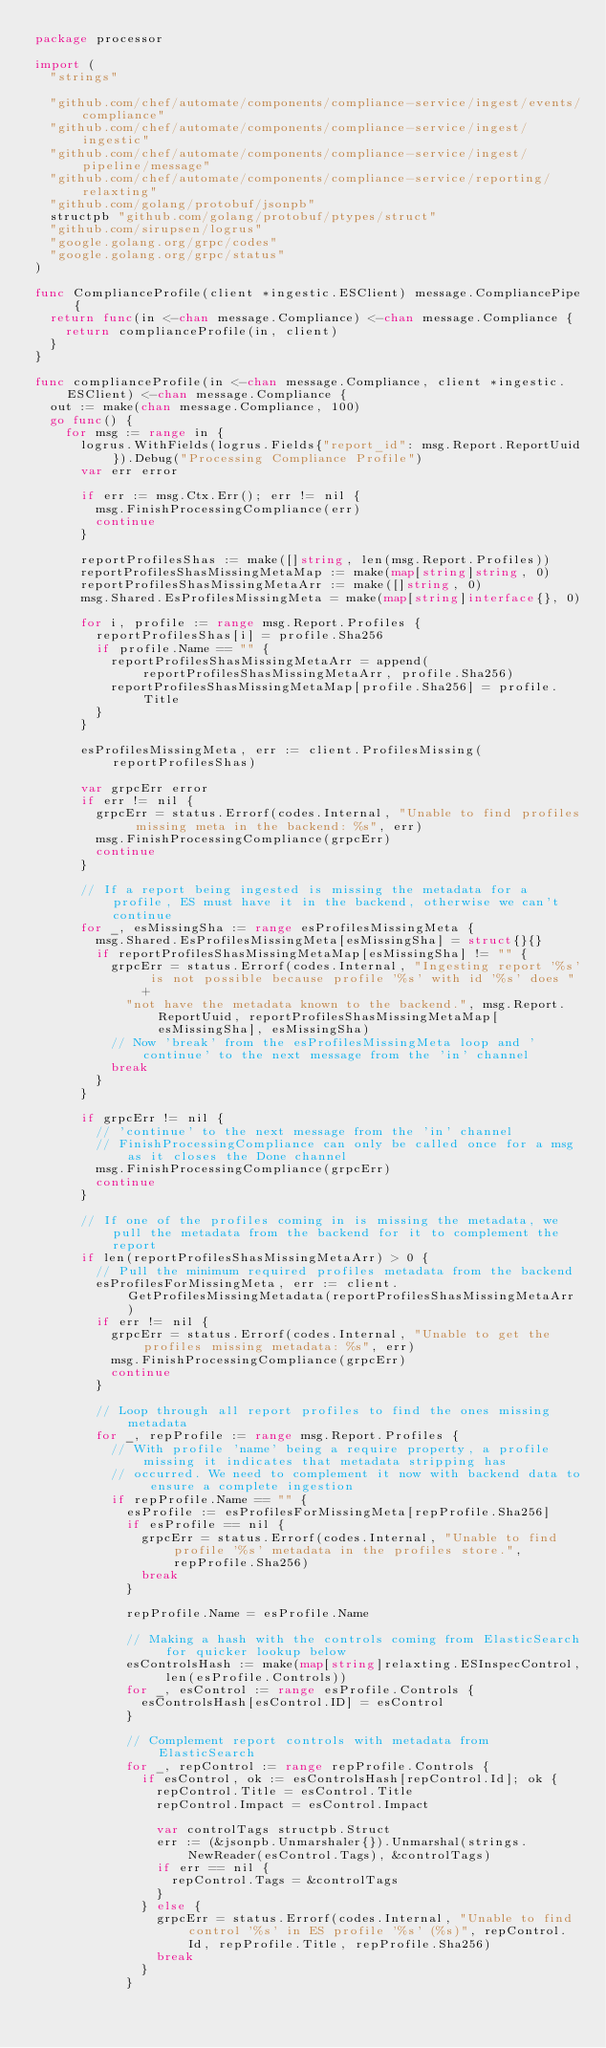Convert code to text. <code><loc_0><loc_0><loc_500><loc_500><_Go_>package processor

import (
	"strings"

	"github.com/chef/automate/components/compliance-service/ingest/events/compliance"
	"github.com/chef/automate/components/compliance-service/ingest/ingestic"
	"github.com/chef/automate/components/compliance-service/ingest/pipeline/message"
	"github.com/chef/automate/components/compliance-service/reporting/relaxting"
	"github.com/golang/protobuf/jsonpb"
	structpb "github.com/golang/protobuf/ptypes/struct"
	"github.com/sirupsen/logrus"
	"google.golang.org/grpc/codes"
	"google.golang.org/grpc/status"
)

func ComplianceProfile(client *ingestic.ESClient) message.CompliancePipe {
	return func(in <-chan message.Compliance) <-chan message.Compliance {
		return complianceProfile(in, client)
	}
}

func complianceProfile(in <-chan message.Compliance, client *ingestic.ESClient) <-chan message.Compliance {
	out := make(chan message.Compliance, 100)
	go func() {
		for msg := range in {
			logrus.WithFields(logrus.Fields{"report_id": msg.Report.ReportUuid}).Debug("Processing Compliance Profile")
			var err error

			if err := msg.Ctx.Err(); err != nil {
				msg.FinishProcessingCompliance(err)
				continue
			}

			reportProfilesShas := make([]string, len(msg.Report.Profiles))
			reportProfilesShasMissingMetaMap := make(map[string]string, 0)
			reportProfilesShasMissingMetaArr := make([]string, 0)
			msg.Shared.EsProfilesMissingMeta = make(map[string]interface{}, 0)

			for i, profile := range msg.Report.Profiles {
				reportProfilesShas[i] = profile.Sha256
				if profile.Name == "" {
					reportProfilesShasMissingMetaArr = append(reportProfilesShasMissingMetaArr, profile.Sha256)
					reportProfilesShasMissingMetaMap[profile.Sha256] = profile.Title
				}
			}

			esProfilesMissingMeta, err := client.ProfilesMissing(reportProfilesShas)

			var grpcErr error
			if err != nil {
				grpcErr = status.Errorf(codes.Internal, "Unable to find profiles missing meta in the backend: %s", err)
				msg.FinishProcessingCompliance(grpcErr)
				continue
			}

			// If a report being ingested is missing the metadata for a profile, ES must have it in the backend, otherwise we can't continue
			for _, esMissingSha := range esProfilesMissingMeta {
				msg.Shared.EsProfilesMissingMeta[esMissingSha] = struct{}{}
				if reportProfilesShasMissingMetaMap[esMissingSha] != "" {
					grpcErr = status.Errorf(codes.Internal, "Ingesting report '%s' is not possible because profile '%s' with id '%s' does "+
						"not have the metadata known to the backend.", msg.Report.ReportUuid, reportProfilesShasMissingMetaMap[esMissingSha], esMissingSha)
					// Now 'break' from the esProfilesMissingMeta loop and 'continue' to the next message from the 'in' channel
					break
				}
			}

			if grpcErr != nil {
				// 'continue' to the next message from the 'in' channel
				// FinishProcessingCompliance can only be called once for a msg as it closes the Done channel
				msg.FinishProcessingCompliance(grpcErr)
				continue
			}

			// If one of the profiles coming in is missing the metadata, we pull the metadata from the backend for it to complement the report
			if len(reportProfilesShasMissingMetaArr) > 0 {
				// Pull the minimum required profiles metadata from the backend
				esProfilesForMissingMeta, err := client.GetProfilesMissingMetadata(reportProfilesShasMissingMetaArr)
				if err != nil {
					grpcErr = status.Errorf(codes.Internal, "Unable to get the profiles missing metadata: %s", err)
					msg.FinishProcessingCompliance(grpcErr)
					continue
				}

				// Loop through all report profiles to find the ones missing metadata
				for _, repProfile := range msg.Report.Profiles {
					// With profile 'name' being a require property, a profile missing it indicates that metadata stripping has
					// occurred. We need to complement it now with backend data to ensure a complete ingestion
					if repProfile.Name == "" {
						esProfile := esProfilesForMissingMeta[repProfile.Sha256]
						if esProfile == nil {
							grpcErr = status.Errorf(codes.Internal, "Unable to find profile '%s' metadata in the profiles store.", repProfile.Sha256)
							break
						}

						repProfile.Name = esProfile.Name

						// Making a hash with the controls coming from ElasticSearch for quicker lookup below
						esControlsHash := make(map[string]relaxting.ESInspecControl, len(esProfile.Controls))
						for _, esControl := range esProfile.Controls {
							esControlsHash[esControl.ID] = esControl
						}

						// Complement report controls with metadata from ElasticSearch
						for _, repControl := range repProfile.Controls {
							if esControl, ok := esControlsHash[repControl.Id]; ok {
								repControl.Title = esControl.Title
								repControl.Impact = esControl.Impact

								var controlTags structpb.Struct
								err := (&jsonpb.Unmarshaler{}).Unmarshal(strings.NewReader(esControl.Tags), &controlTags)
								if err == nil {
									repControl.Tags = &controlTags
								}
							} else {
								grpcErr = status.Errorf(codes.Internal, "Unable to find control '%s' in ES profile '%s' (%s)", repControl.Id, repProfile.Title, repProfile.Sha256)
								break
							}
						}</code> 